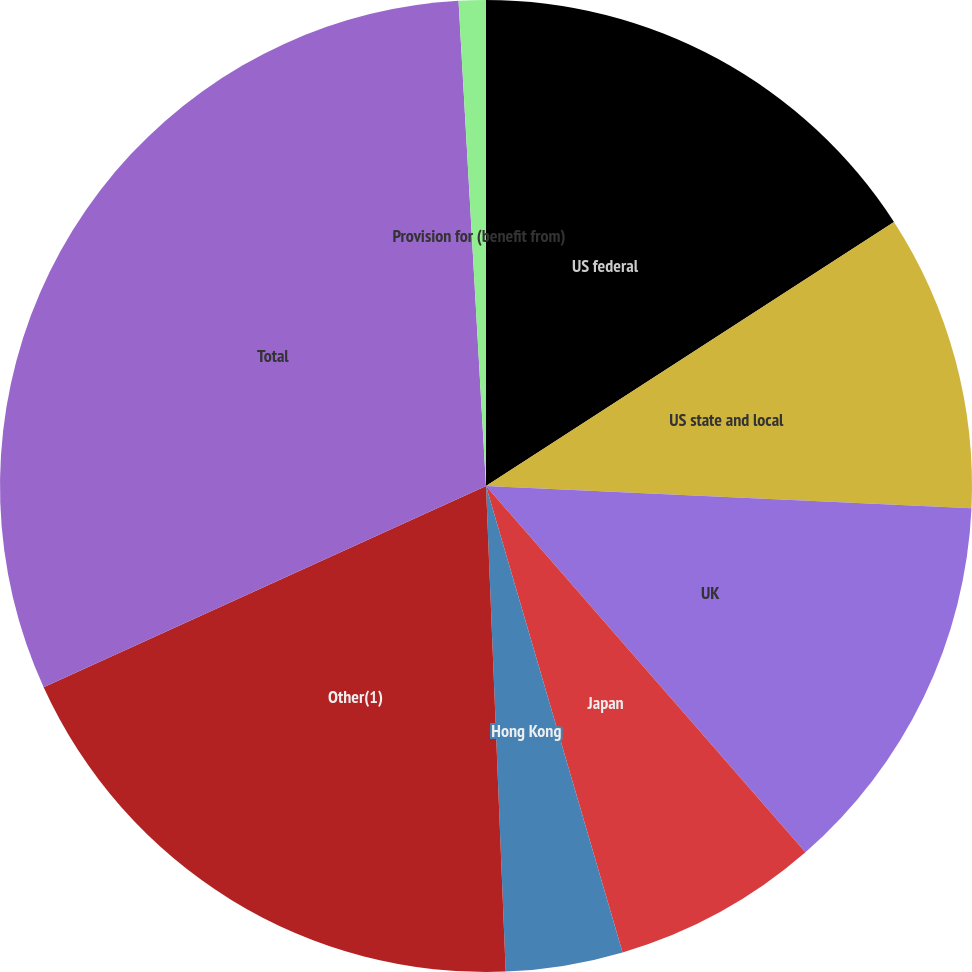Convert chart to OTSL. <chart><loc_0><loc_0><loc_500><loc_500><pie_chart><fcel>US federal<fcel>US state and local<fcel>UK<fcel>Japan<fcel>Hong Kong<fcel>Other(1)<fcel>Total<fcel>Provision for (benefit from)<nl><fcel>15.86%<fcel>9.87%<fcel>12.86%<fcel>6.88%<fcel>3.89%<fcel>18.85%<fcel>30.9%<fcel>0.9%<nl></chart> 